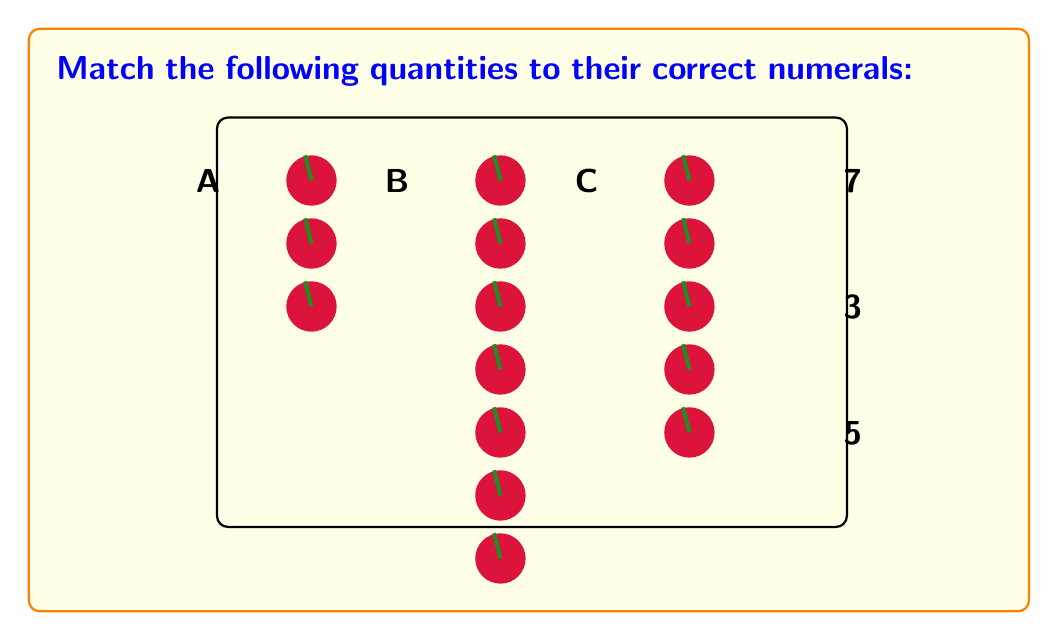Provide a solution to this math problem. To match quantities to their corresponding numerals, we need to count the number of apples in each group and then pair them with the correct numeral. Let's go through this step-by-step:

1. Group A:
   Count the apples: $1, 2, 3$
   There are $3$ apples in group A.

2. Group B:
   Count the apples: $1, 2, 3, 4, 5, 6, 7$
   There are $7$ apples in group B.

3. Group C:
   Count the apples: $1, 2, 3, 4, 5$
   There are $5$ apples in group C.

4. Now, let's match these quantities to the given numerals:
   - Group A has 3 apples, which matches the numeral 3.
   - Group B has 7 apples, which matches the numeral 7.
   - Group C has 5 apples, which matches the numeral 5.

Therefore, the correct matching is:
A → 3
B → 7
C → 5
Answer: A-3, B-7, C-5 